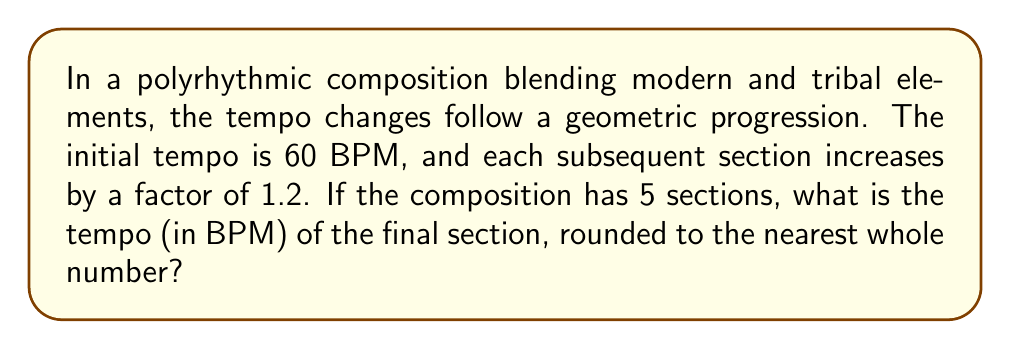Show me your answer to this math problem. Let's approach this step-by-step:

1) We're dealing with a geometric progression where:
   - Initial term (a) = 60 BPM
   - Common ratio (r) = 1.2
   - Number of terms (n) = 5

2) In a geometric progression, the nth term is given by the formula:
   $$a_n = a \cdot r^{n-1}$$

3) We want to find the 5th term (the final section's tempo), so:
   $$a_5 = 60 \cdot 1.2^{5-1}$$

4) Let's calculate:
   $$a_5 = 60 \cdot 1.2^4$$

5) Evaluate 1.2^4:
   $$1.2^4 = 1.2 \cdot 1.2 \cdot 1.2 \cdot 1.2 = 2.0736$$

6) Multiply:
   $$a_5 = 60 \cdot 2.0736 = 124.416$$

7) Rounding to the nearest whole number:
   $$124.416 \approx 124 \text{ BPM}$$

Therefore, the tempo of the final section is 124 BPM.
Answer: 124 BPM 